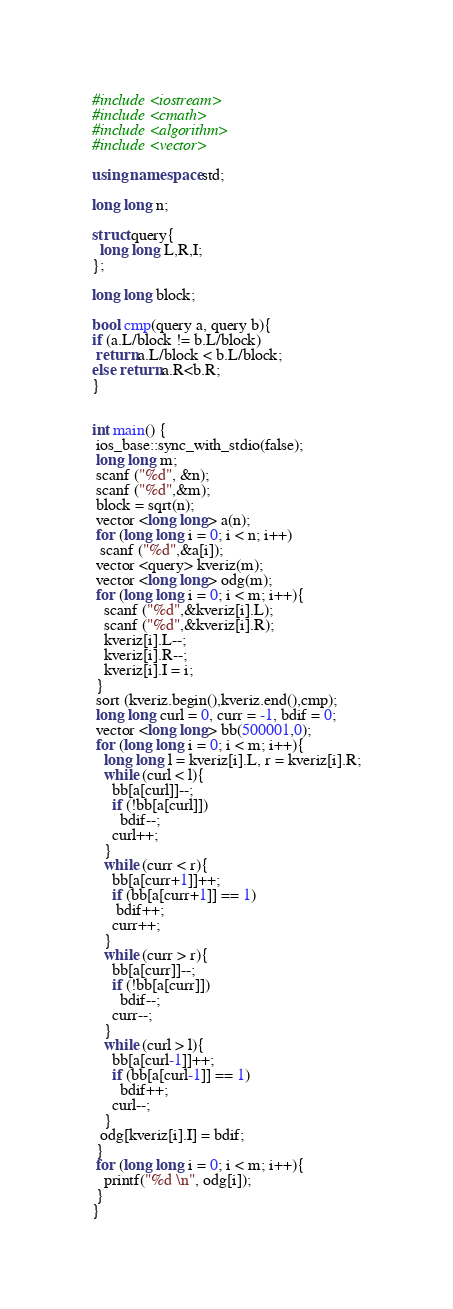Convert code to text. <code><loc_0><loc_0><loc_500><loc_500><_C++_>#include <iostream>
#include <cmath>
#include <algorithm>
#include <vector>

using namespace std;

long long n;

struct query{
  long long L,R,I;
};

long long block;

bool cmp(query a, query b){
if (a.L/block != b.L/block)
 return a.L/block < b.L/block;
else return a.R<b.R;
}


int main() {
 ios_base::sync_with_stdio(false);
 long long m;
 scanf ("%d", &n);
 scanf ("%d",&m);
 block = sqrt(n);
 vector <long long> a(n);
 for (long long i = 0; i < n; i++)
  scanf ("%d",&a[i]);
 vector <query> kveriz(m);
 vector <long long> odg(m);
 for (long long i = 0; i < m; i++){
   scanf ("%d",&kveriz[i].L);
   scanf ("%d",&kveriz[i].R);
   kveriz[i].L--;
   kveriz[i].R--;
   kveriz[i].I = i;
 }
 sort (kveriz.begin(),kveriz.end(),cmp);
 long long curl = 0, curr = -1, bdif = 0;
 vector <long long> bb(500001,0);
 for (long long i = 0; i < m; i++){
   long long l = kveriz[i].L, r = kveriz[i].R;
   while (curl < l){
     bb[a[curl]]--;
     if (!bb[a[curl]])
       bdif--;
     curl++;
   }
   while (curr < r){
     bb[a[curr+1]]++;
     if (bb[a[curr+1]] == 1)
      bdif++;
     curr++;
   }
   while (curr > r){
     bb[a[curr]]--;
     if (!bb[a[curr]])
       bdif--;
     curr--;
   }
   while (curl > l){
     bb[a[curl-1]]++;
     if (bb[a[curl-1]] == 1)
       bdif++;
     curl--;
   }
  odg[kveriz[i].I] = bdif;
 }
 for (long long i = 0; i < m; i++){
   printf("%d \n", odg[i]);
 }
}
</code> 